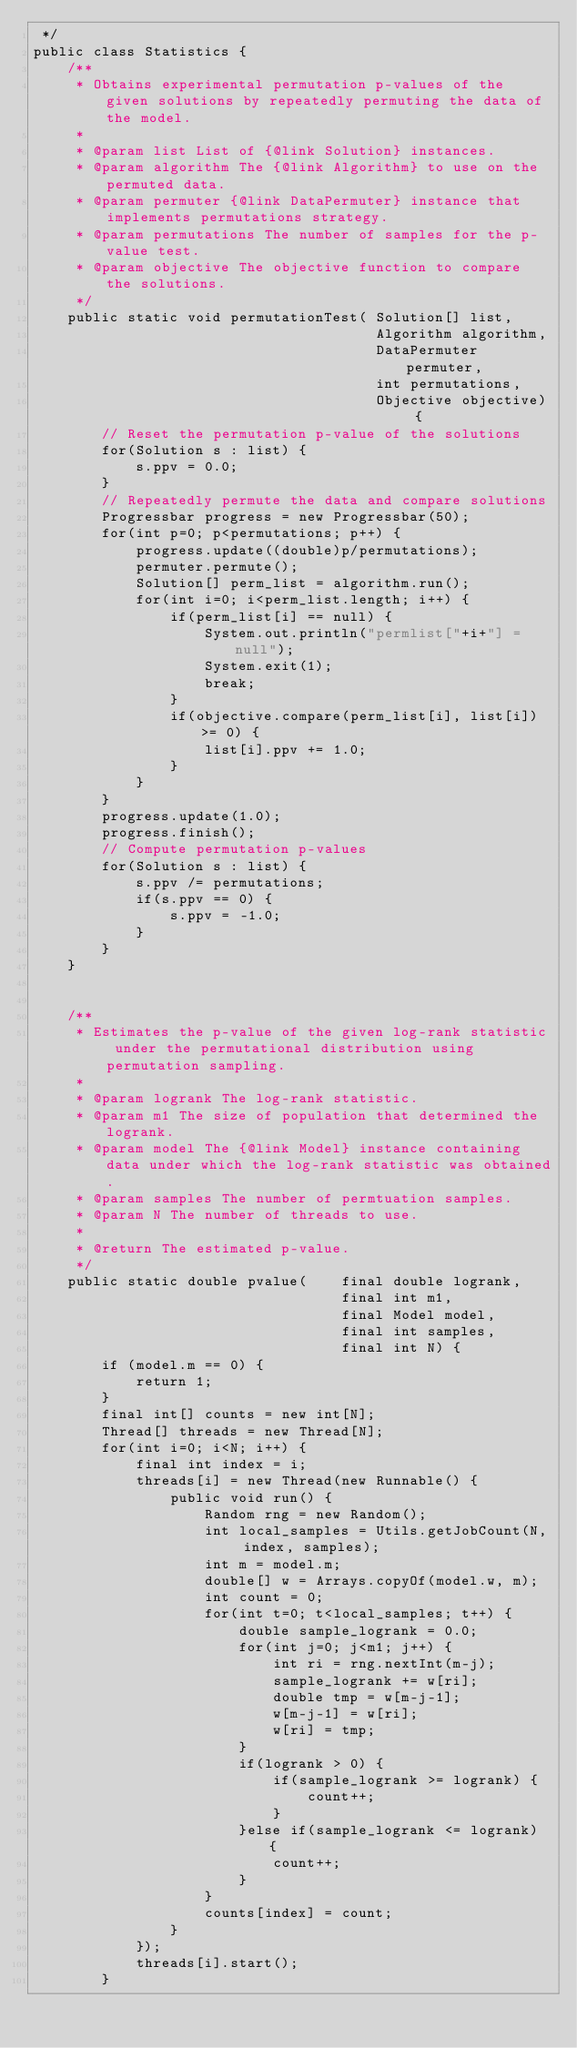<code> <loc_0><loc_0><loc_500><loc_500><_Java_> */
public class Statistics {
	/**
	 * Obtains experimental permutation p-values of the given solutions by repeatedly permuting the data of the model.
	 *
	 * @param list List of {@link Solution} instances.
	 * @param algorithm The {@link Algorithm} to use on the permuted data.
	 * @param permuter {@link DataPermuter} instance that implements permutations strategy.
	 * @param permutations The number of samples for the p-value test.
	 * @param objective The objective function to compare the solutions.
	 */
	public static void permutationTest(	Solution[] list,
										Algorithm algorithm,
										DataPermuter permuter,
										int permutations,
										Objective objective) {
		// Reset the permutation p-value of the solutions
		for(Solution s : list) {
			s.ppv = 0.0;
		}
		// Repeatedly permute the data and compare solutions
		Progressbar progress = new Progressbar(50);
		for(int p=0; p<permutations; p++) {
			progress.update((double)p/permutations);
			permuter.permute();
			Solution[] perm_list = algorithm.run();
			for(int i=0; i<perm_list.length; i++) {
				if(perm_list[i] == null) {
					System.out.println("permlist["+i+"] = null");
					System.exit(1);
					break;
				}
				if(objective.compare(perm_list[i], list[i]) >= 0) {
					list[i].ppv += 1.0;
				}
			}
		}
		progress.update(1.0);
		progress.finish();
		// Compute permutation p-values
		for(Solution s : list) {
			s.ppv /= permutations;
			if(s.ppv == 0) {
				s.ppv = -1.0;
			}
		}
	}
	
	
	/**
	 * Estimates the p-value of the given log-rank statistic under the permutational distribution using permutation sampling.
	 *
	 * @param logrank The log-rank statistic.
	 * @param m1 The size of population that determined the logrank.
	 * @param model The {@link Model} instance containing data under which the log-rank statistic was obtained.
	 * @param samples The number of permtuation samples.
	 * @param N The number of threads to use.
	 *
	 * @return The estimated p-value.
	 */
	public static double pvalue(	final double logrank,
									final int m1,
									final Model model,
									final int samples,
									final int N) {
		if (model.m == 0) {
			return 1;
		}
		final int[] counts = new int[N];
		Thread[] threads = new Thread[N];
		for(int i=0; i<N; i++) {
			final int index = i;
			threads[i] = new Thread(new Runnable() {
				public void run() {
					Random rng = new Random();
					int local_samples = Utils.getJobCount(N, index, samples);
					int m = model.m;
					double[] w = Arrays.copyOf(model.w, m);
					int count = 0;
					for(int t=0; t<local_samples; t++) {
						double sample_logrank = 0.0;
						for(int j=0; j<m1; j++) {
							int ri = rng.nextInt(m-j);
							sample_logrank += w[ri];
							double tmp = w[m-j-1];
							w[m-j-1] = w[ri];
							w[ri] = tmp;
						}
						if(logrank > 0) {
							if(sample_logrank >= logrank) {
								count++;
							}
						}else if(sample_logrank <= logrank) {
							count++;
						}
					}
					counts[index] = count;
				}
			});
			threads[i].start();
		}</code> 